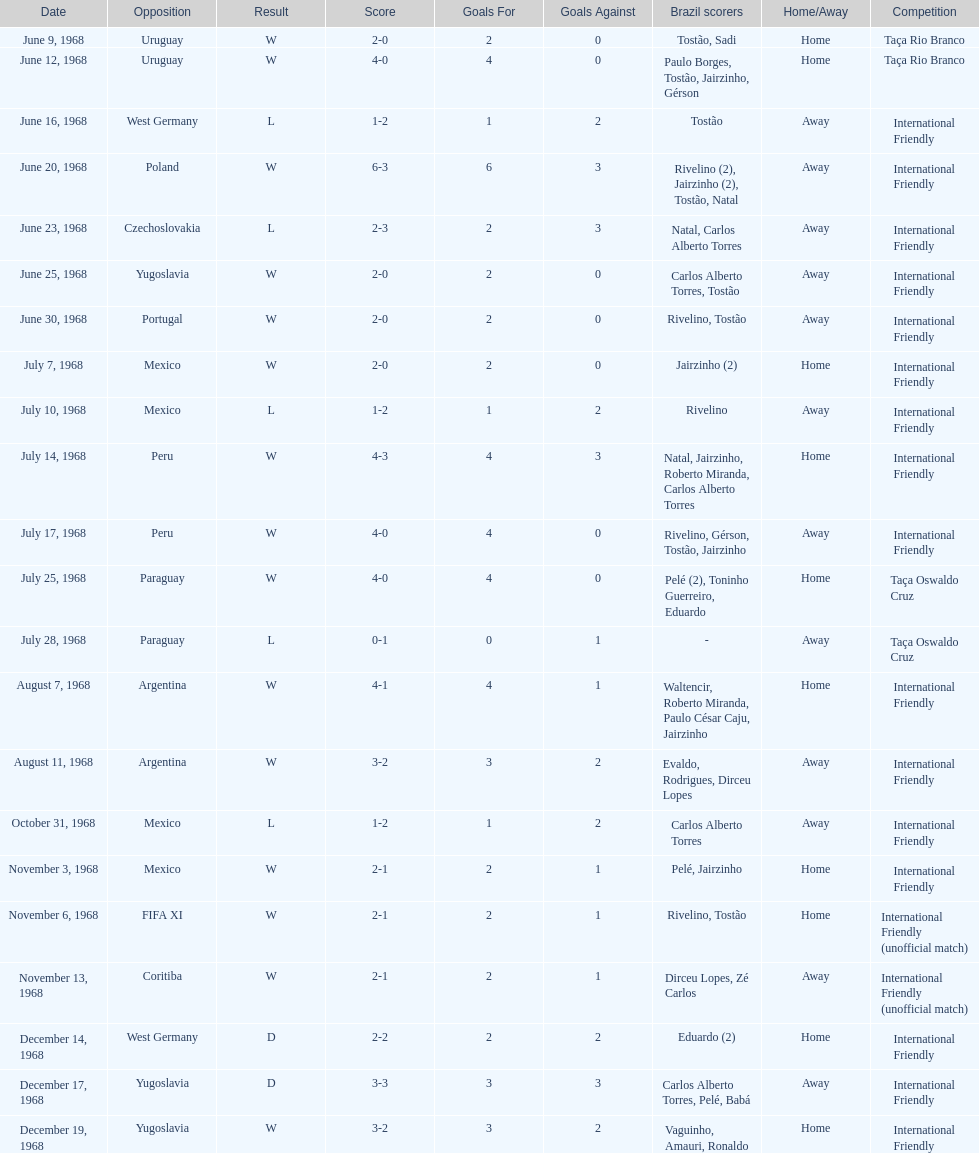Number of losses 5. 